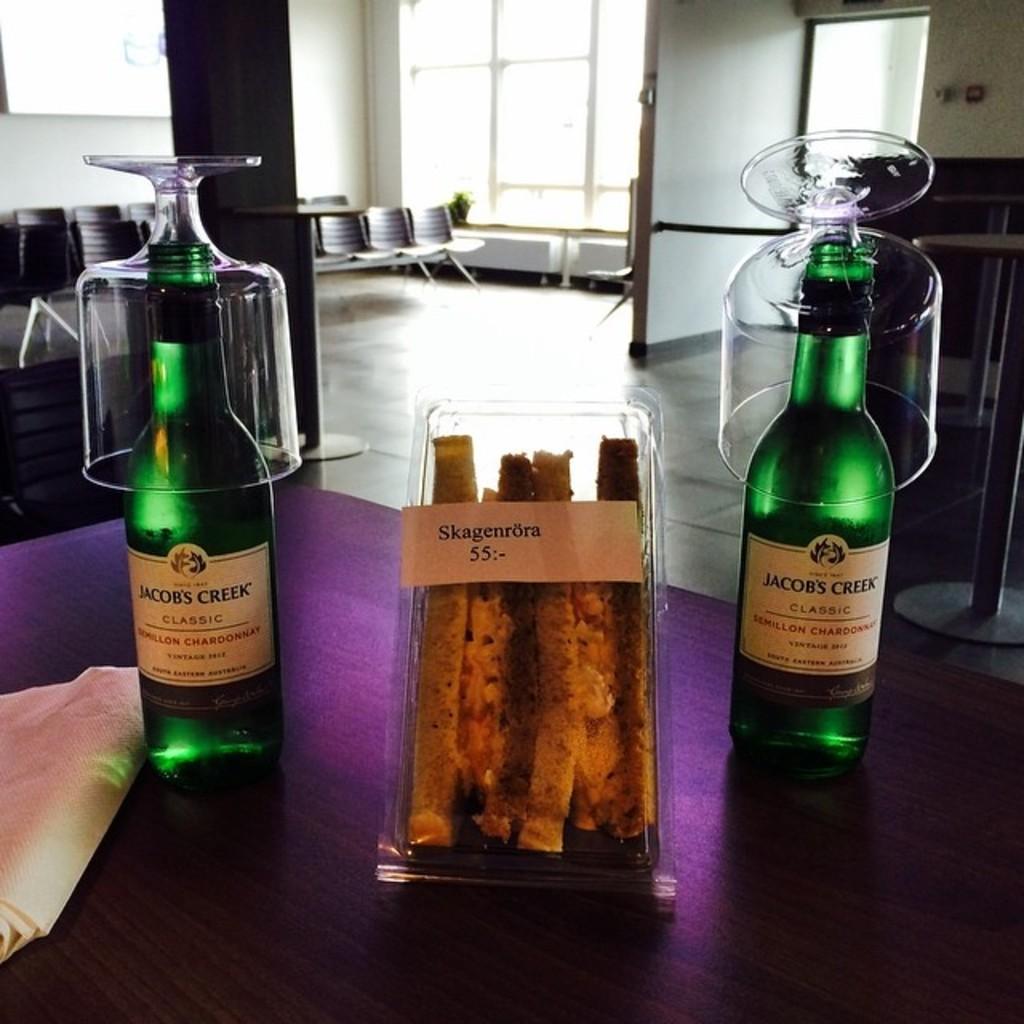What number is on the sandwich?
Your response must be concise. 55. Who makes the chardonnay?
Your answer should be compact. Jacob's creek. 